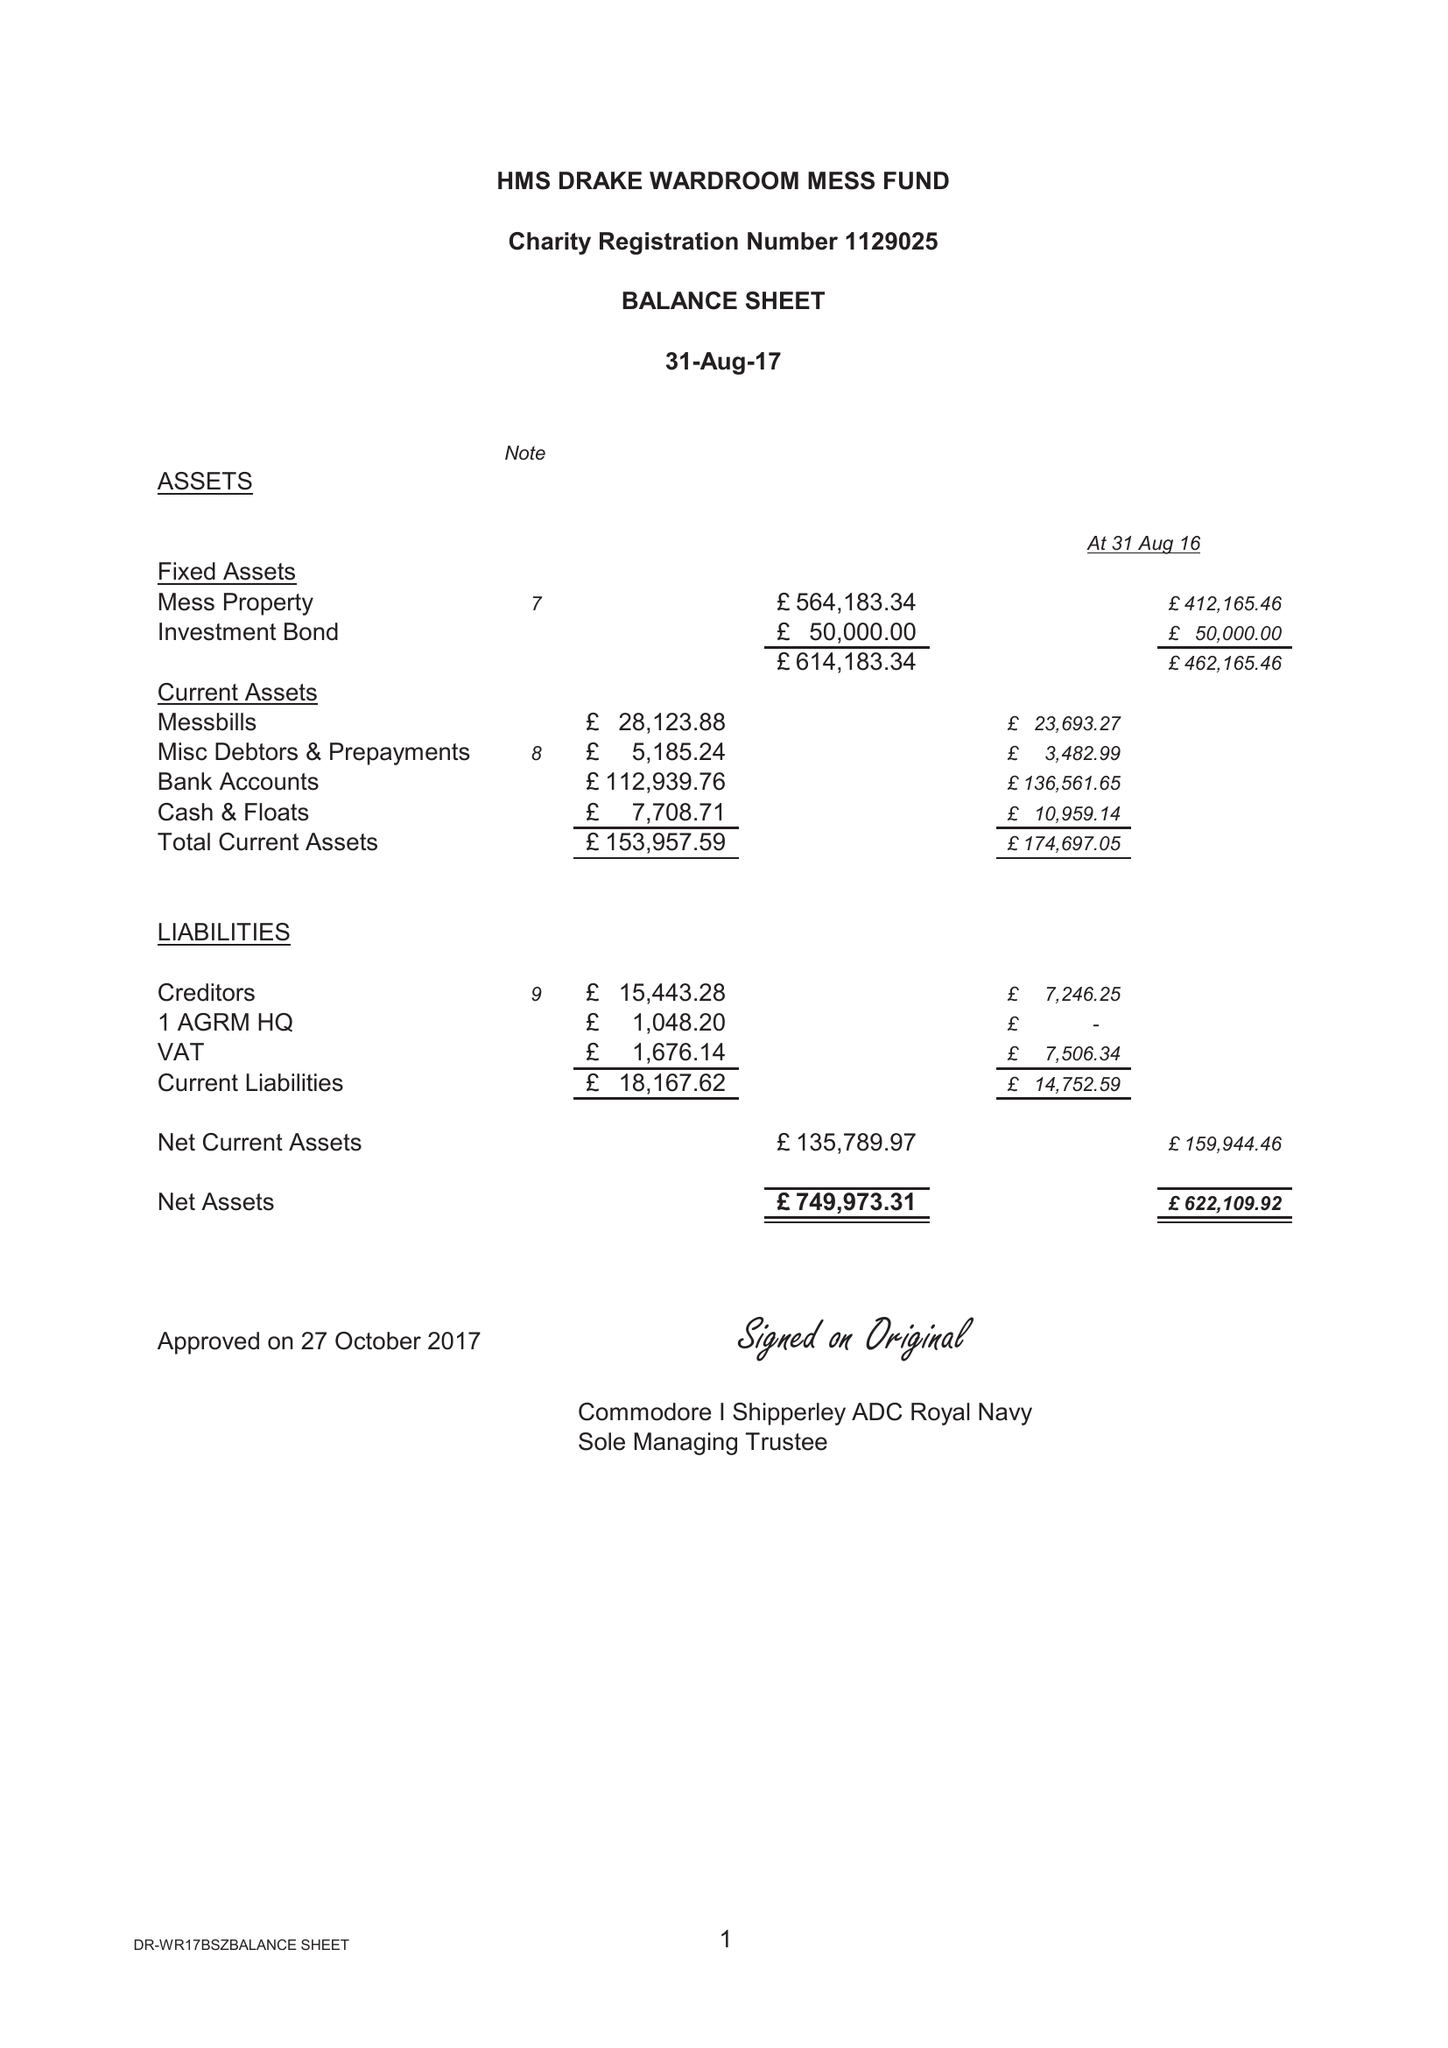What is the value for the address__post_town?
Answer the question using a single word or phrase. PLYMOUTH 